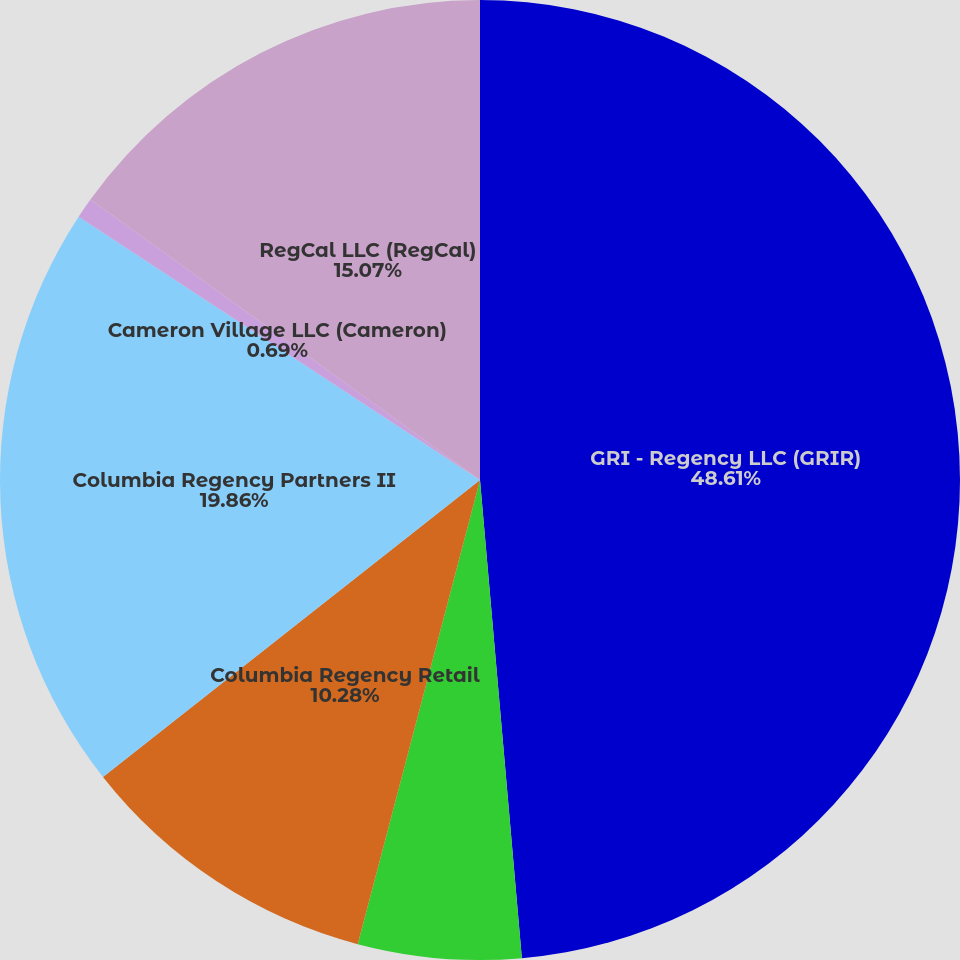Convert chart to OTSL. <chart><loc_0><loc_0><loc_500><loc_500><pie_chart><fcel>GRI - Regency LLC (GRIR)<fcel>New York Common Retirement<fcel>Columbia Regency Retail<fcel>Columbia Regency Partners II<fcel>Cameron Village LLC (Cameron)<fcel>RegCal LLC (RegCal)<nl><fcel>48.61%<fcel>5.49%<fcel>10.28%<fcel>19.86%<fcel>0.69%<fcel>15.07%<nl></chart> 